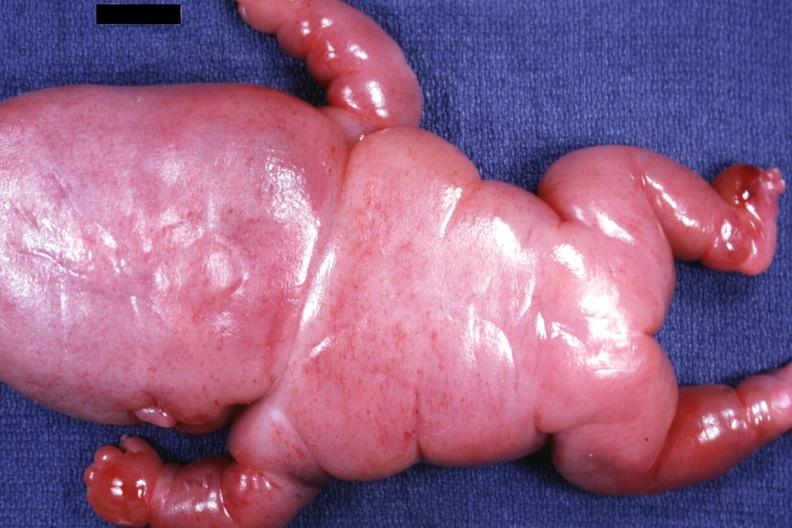does this image show posterior view of body slide?
Answer the question using a single word or phrase. Yes 